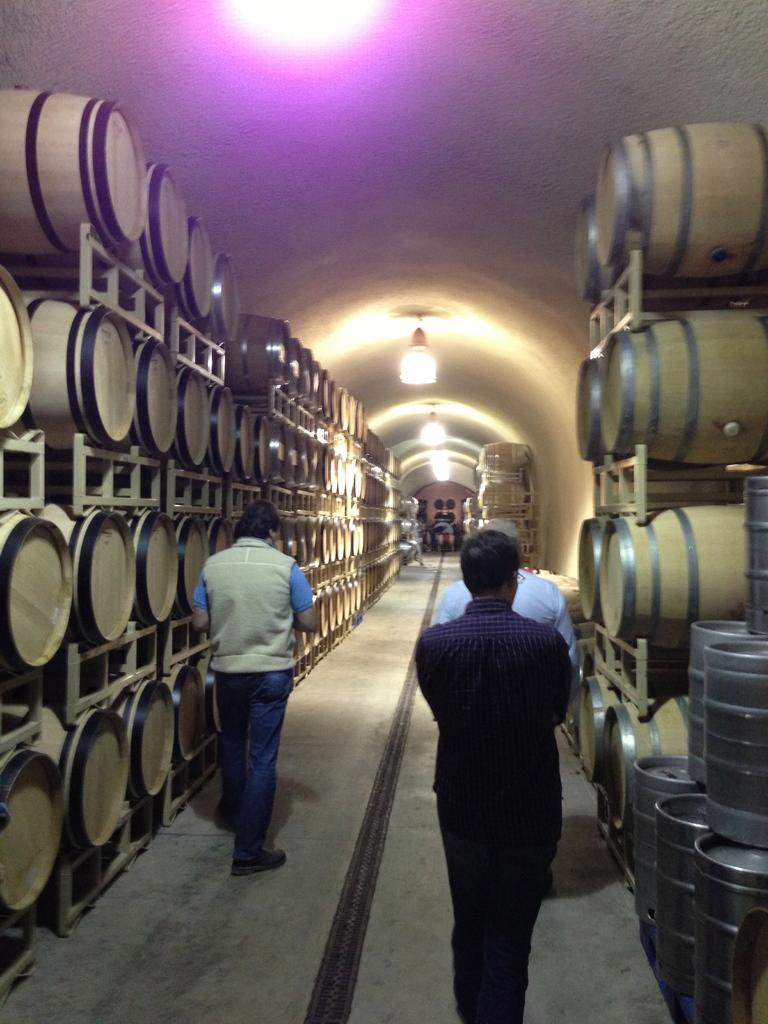How many men are present in the image? There are three men standing in the image. What can be seen on either side of the image? There are barrels on either side of the image. What is located at the top of the image? There are lights on the top of the image. How many heads are visible on the men in the image? There is no specific number of heads mentioned in the facts, but since there are three men, there are at least three heads visible. Can you tell me how many snakes are slithering around the men in the image? There is no mention of snakes in the image; the facts only mention the three men and the barrels. What type of pin is holding the barrels together in the image? There is no mention of a pin or any object holding the barrels together in the image. 